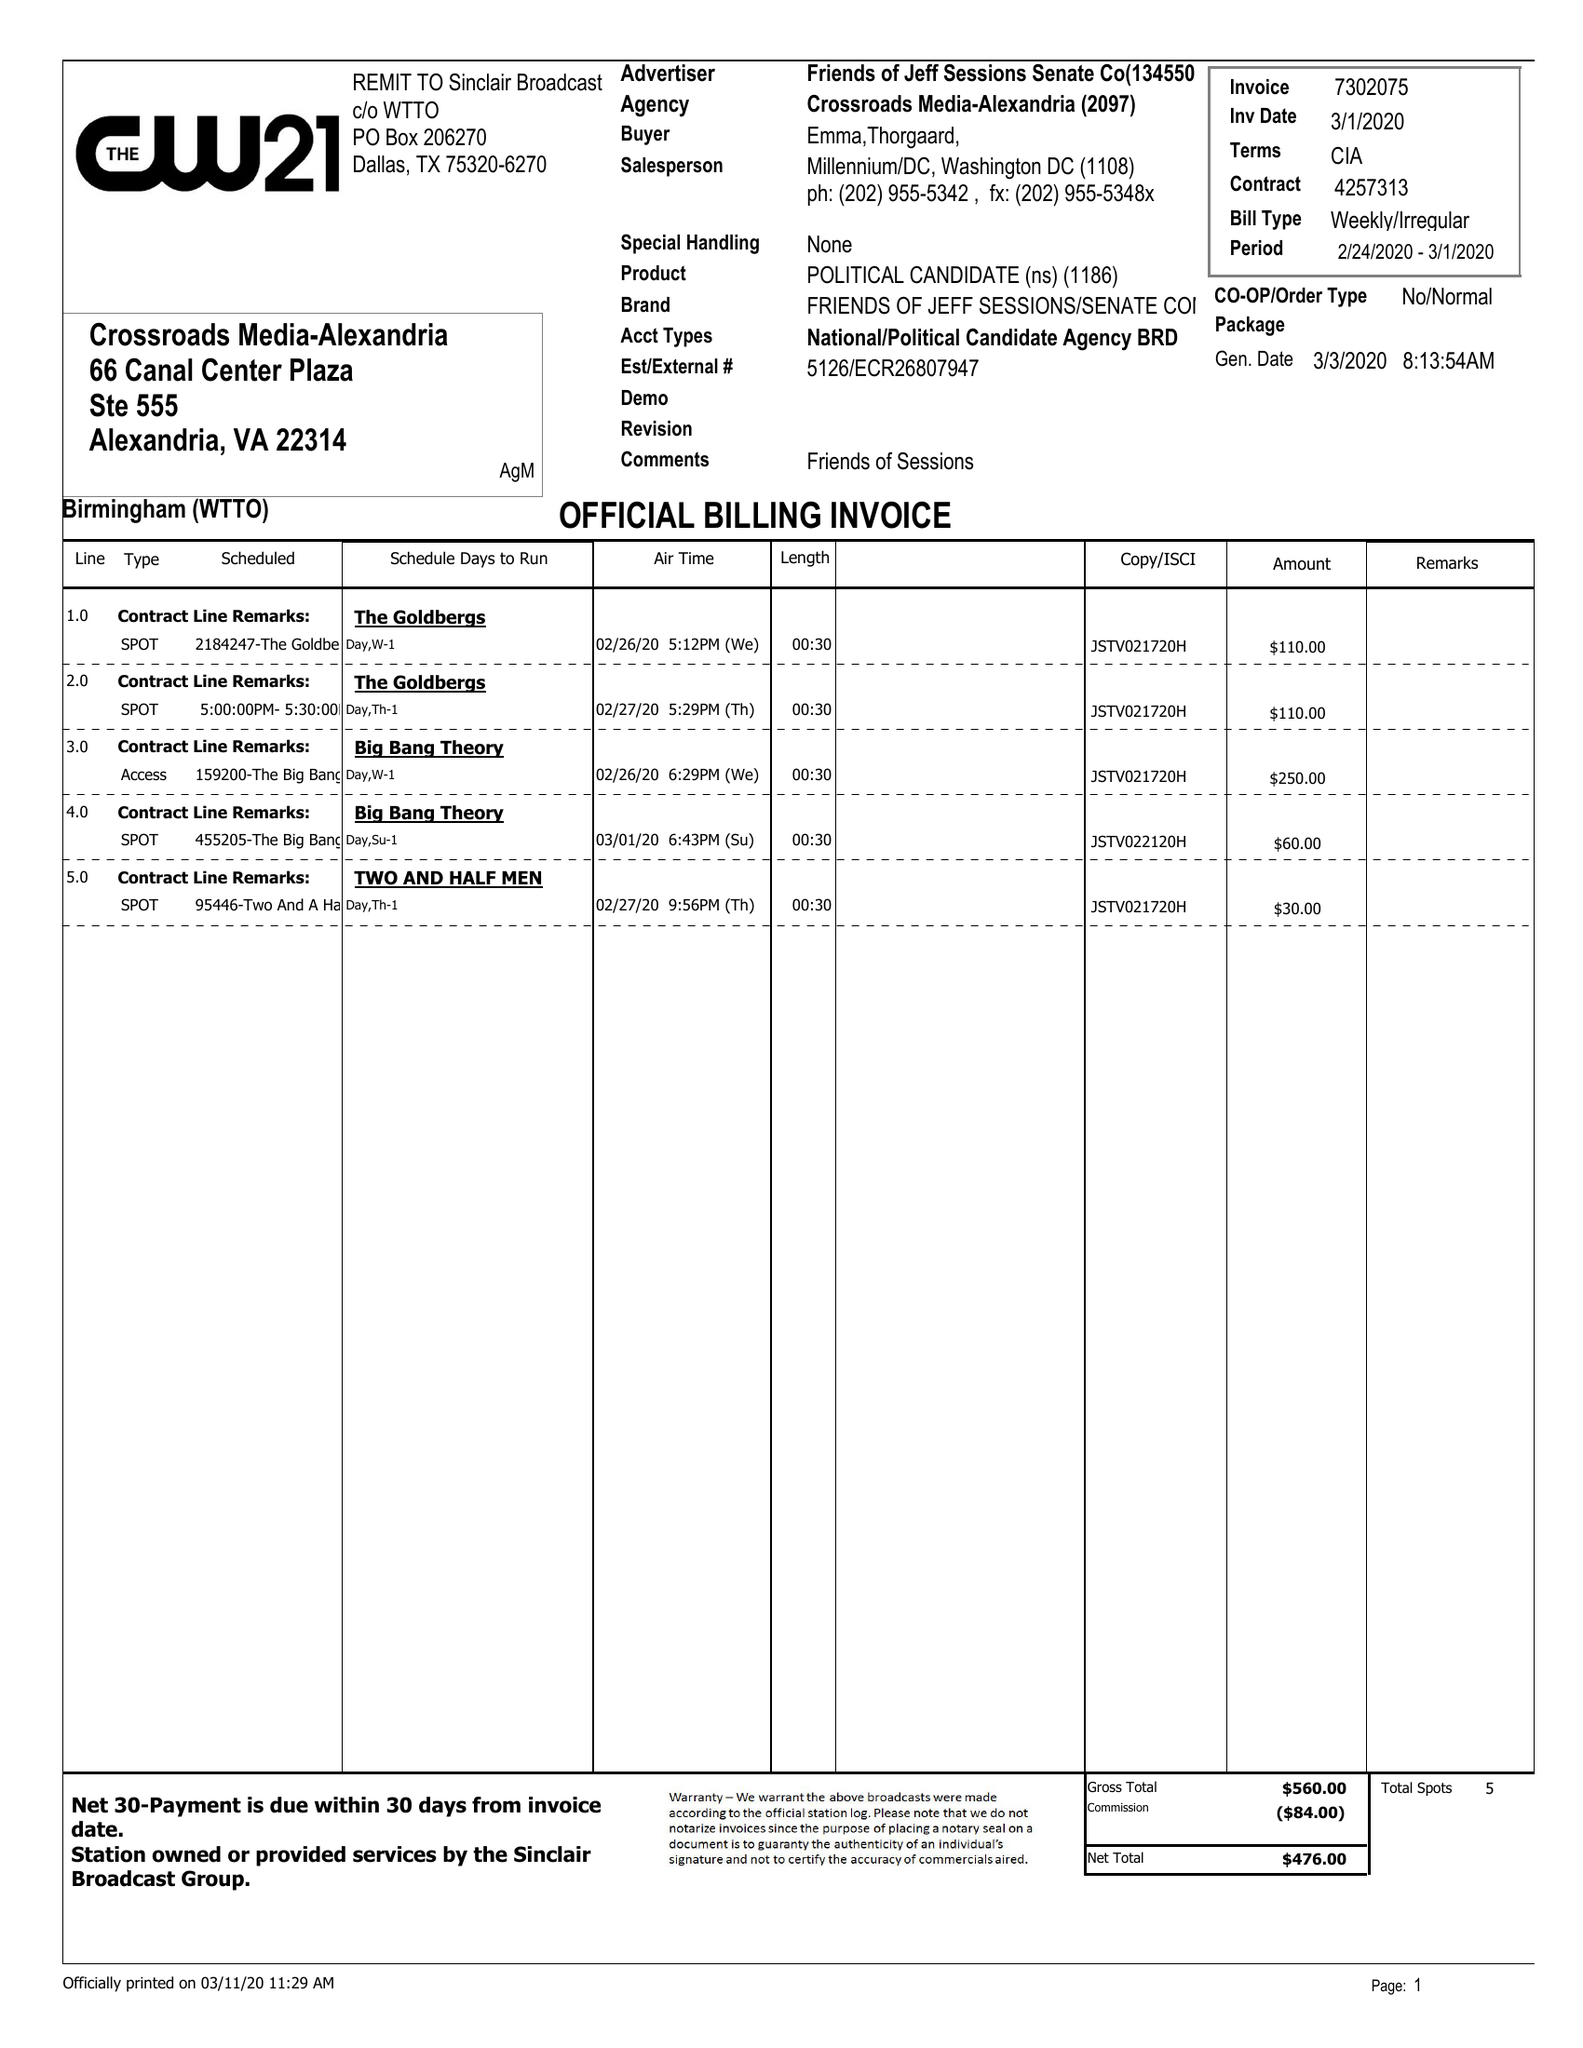What is the value for the flight_from?
Answer the question using a single word or phrase. 02/24/20 